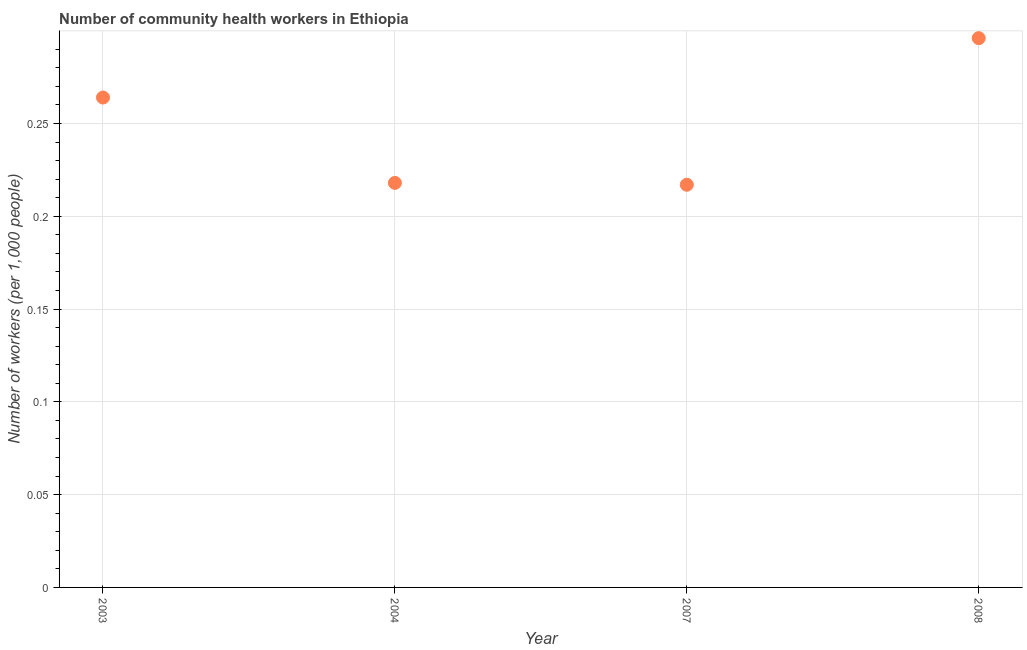What is the number of community health workers in 2007?
Provide a succinct answer. 0.22. Across all years, what is the maximum number of community health workers?
Your answer should be compact. 0.3. Across all years, what is the minimum number of community health workers?
Keep it short and to the point. 0.22. In which year was the number of community health workers maximum?
Provide a succinct answer. 2008. In which year was the number of community health workers minimum?
Give a very brief answer. 2007. What is the sum of the number of community health workers?
Keep it short and to the point. 0.99. What is the difference between the number of community health workers in 2003 and 2007?
Offer a very short reply. 0.05. What is the average number of community health workers per year?
Your answer should be very brief. 0.25. What is the median number of community health workers?
Offer a very short reply. 0.24. In how many years, is the number of community health workers greater than 0.2 ?
Give a very brief answer. 4. What is the ratio of the number of community health workers in 2003 to that in 2004?
Your response must be concise. 1.21. Is the difference between the number of community health workers in 2004 and 2008 greater than the difference between any two years?
Make the answer very short. No. What is the difference between the highest and the second highest number of community health workers?
Make the answer very short. 0.03. What is the difference between the highest and the lowest number of community health workers?
Provide a succinct answer. 0.08. Does the number of community health workers monotonically increase over the years?
Keep it short and to the point. No. How many dotlines are there?
Your response must be concise. 1. How many years are there in the graph?
Offer a very short reply. 4. What is the difference between two consecutive major ticks on the Y-axis?
Provide a short and direct response. 0.05. Are the values on the major ticks of Y-axis written in scientific E-notation?
Keep it short and to the point. No. Does the graph contain any zero values?
Your response must be concise. No. Does the graph contain grids?
Provide a succinct answer. Yes. What is the title of the graph?
Keep it short and to the point. Number of community health workers in Ethiopia. What is the label or title of the X-axis?
Your answer should be very brief. Year. What is the label or title of the Y-axis?
Offer a terse response. Number of workers (per 1,0 people). What is the Number of workers (per 1,000 people) in 2003?
Offer a very short reply. 0.26. What is the Number of workers (per 1,000 people) in 2004?
Make the answer very short. 0.22. What is the Number of workers (per 1,000 people) in 2007?
Offer a terse response. 0.22. What is the Number of workers (per 1,000 people) in 2008?
Give a very brief answer. 0.3. What is the difference between the Number of workers (per 1,000 people) in 2003 and 2004?
Provide a succinct answer. 0.05. What is the difference between the Number of workers (per 1,000 people) in 2003 and 2007?
Your response must be concise. 0.05. What is the difference between the Number of workers (per 1,000 people) in 2003 and 2008?
Offer a very short reply. -0.03. What is the difference between the Number of workers (per 1,000 people) in 2004 and 2007?
Keep it short and to the point. 0. What is the difference between the Number of workers (per 1,000 people) in 2004 and 2008?
Provide a short and direct response. -0.08. What is the difference between the Number of workers (per 1,000 people) in 2007 and 2008?
Offer a very short reply. -0.08. What is the ratio of the Number of workers (per 1,000 people) in 2003 to that in 2004?
Keep it short and to the point. 1.21. What is the ratio of the Number of workers (per 1,000 people) in 2003 to that in 2007?
Make the answer very short. 1.22. What is the ratio of the Number of workers (per 1,000 people) in 2003 to that in 2008?
Your response must be concise. 0.89. What is the ratio of the Number of workers (per 1,000 people) in 2004 to that in 2007?
Your response must be concise. 1. What is the ratio of the Number of workers (per 1,000 people) in 2004 to that in 2008?
Your answer should be very brief. 0.74. What is the ratio of the Number of workers (per 1,000 people) in 2007 to that in 2008?
Your answer should be compact. 0.73. 